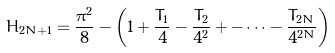Convert formula to latex. <formula><loc_0><loc_0><loc_500><loc_500>H _ { 2 N + 1 } = \frac { \pi ^ { 2 } } { 8 } - \left ( 1 + \frac { T _ { 1 } } { 4 } - \frac { T _ { 2 } } { 4 ^ { 2 } } + - \cdots - \frac { T _ { 2 N } } { 4 ^ { 2 N } } \right )</formula> 